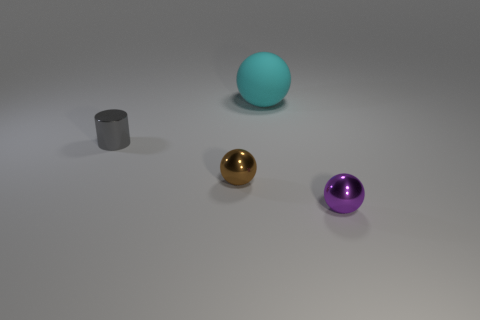There is a thing that is both behind the brown ball and to the right of the metal cylinder; how big is it?
Your response must be concise. Large. Is the material of the cylinder the same as the tiny thing on the right side of the small brown metallic thing?
Make the answer very short. Yes. What number of other small brown objects have the same shape as the small brown thing?
Give a very brief answer. 0. How many small purple cylinders are there?
Offer a very short reply. 0. Is the shape of the matte object the same as the tiny gray shiny thing that is behind the small purple metal ball?
Your answer should be compact. No. What number of things are brown metal objects or shiny objects to the right of the large rubber ball?
Make the answer very short. 2. There is another tiny brown object that is the same shape as the matte thing; what material is it?
Provide a succinct answer. Metal. There is a tiny thing that is to the right of the cyan matte thing; is its shape the same as the small gray thing?
Ensure brevity in your answer.  No. Is there any other thing that is the same size as the metal cylinder?
Make the answer very short. Yes. Is the number of objects that are behind the big rubber object less than the number of small balls on the left side of the small shiny cylinder?
Your response must be concise. No. 